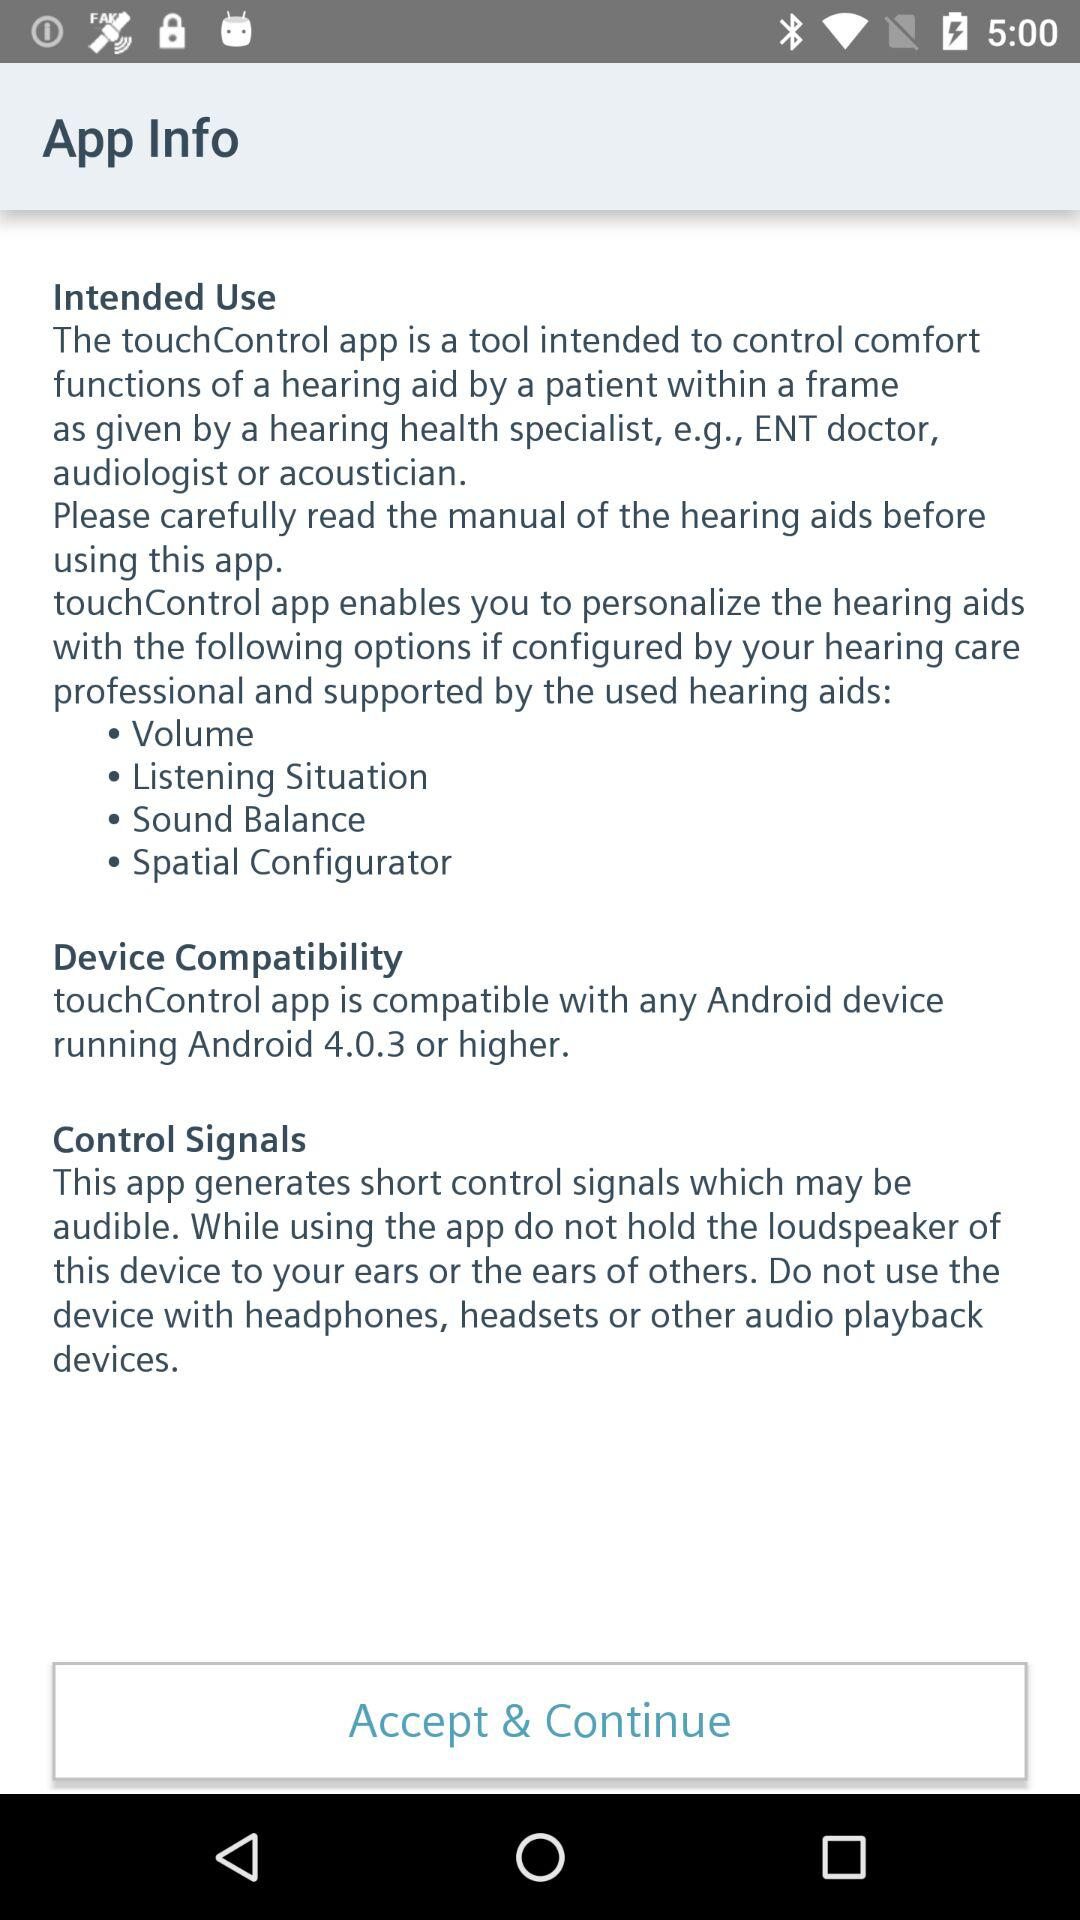How many options are available for personalizing the hearing aids?
Answer the question using a single word or phrase. 4 